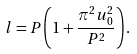Convert formula to latex. <formula><loc_0><loc_0><loc_500><loc_500>l = P \left ( { 1 + \frac { { \pi ^ { 2 } u _ { 0 } ^ { 2 } } } { { P ^ { 2 } } } } \right ) .</formula> 